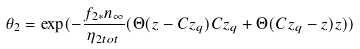Convert formula to latex. <formula><loc_0><loc_0><loc_500><loc_500>\theta _ { 2 } = \exp ( - \frac { f _ { 2 * } n _ { \infty } } { \eta _ { 2 t o t } } ( \Theta ( z - C z _ { q } ) C z _ { q } + \Theta ( C z _ { q } - z ) z ) )</formula> 